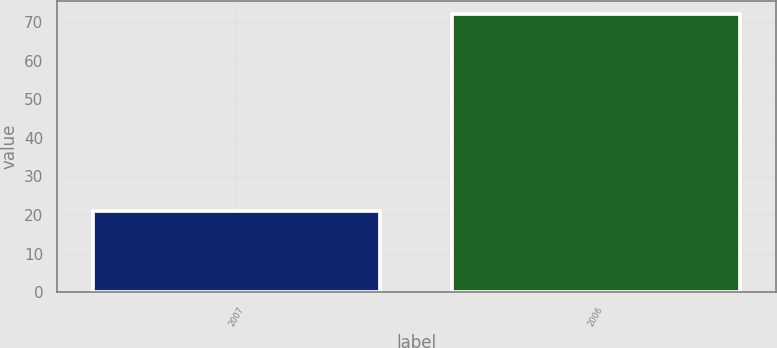Convert chart. <chart><loc_0><loc_0><loc_500><loc_500><bar_chart><fcel>2007<fcel>2006<nl><fcel>21<fcel>72<nl></chart> 